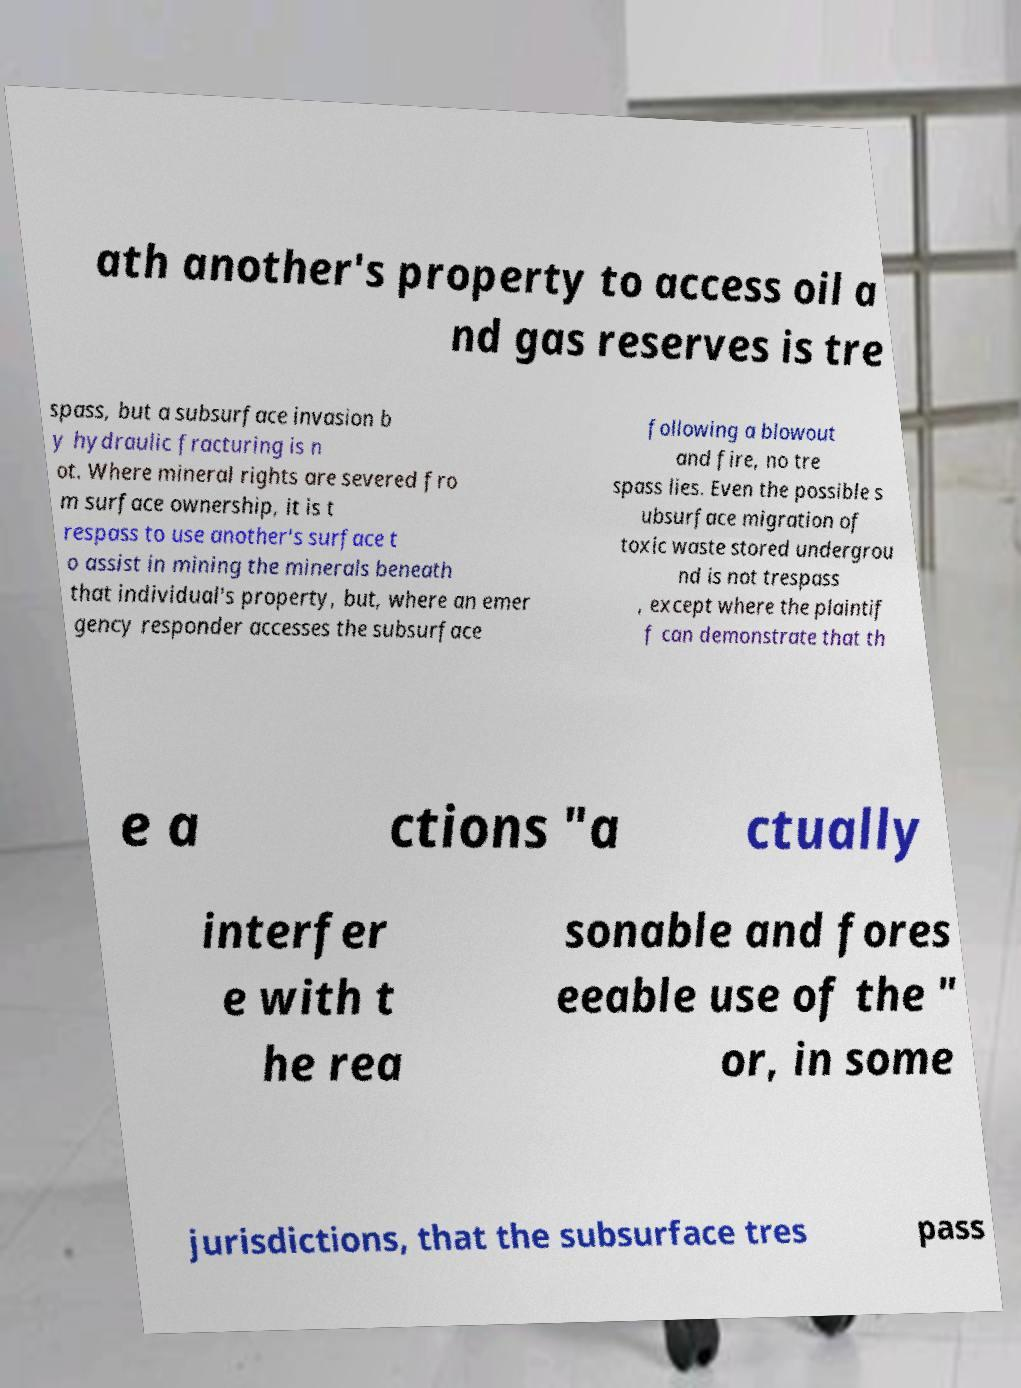Could you assist in decoding the text presented in this image and type it out clearly? ath another's property to access oil a nd gas reserves is tre spass, but a subsurface invasion b y hydraulic fracturing is n ot. Where mineral rights are severed fro m surface ownership, it is t respass to use another's surface t o assist in mining the minerals beneath that individual's property, but, where an emer gency responder accesses the subsurface following a blowout and fire, no tre spass lies. Even the possible s ubsurface migration of toxic waste stored undergrou nd is not trespass , except where the plaintif f can demonstrate that th e a ctions "a ctually interfer e with t he rea sonable and fores eeable use of the " or, in some jurisdictions, that the subsurface tres pass 